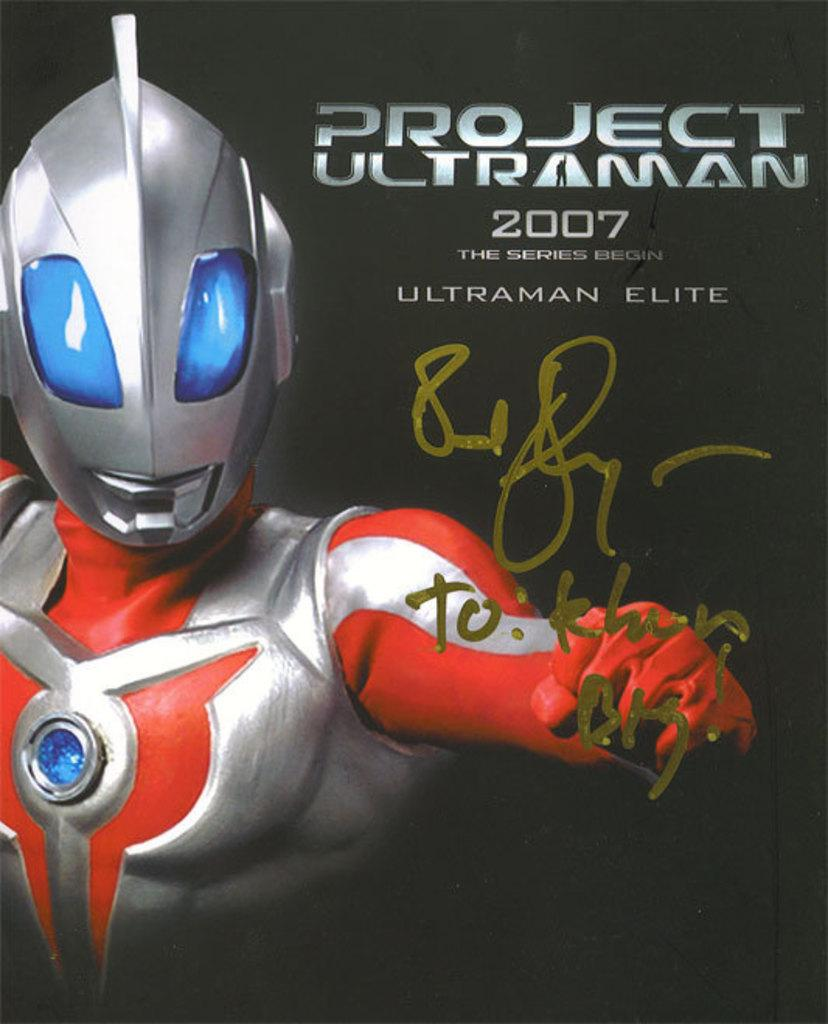What type of image is being described? The image is a poster. What can be seen on the left side of the poster? There is a robot on the left side of the poster. Are there any words or letters on the poster? Yes, there is text on the poster. What color is the background of the poster? The background of the poster is black. How many mice are hiding behind the robot on the poster? There are no mice present on the poster; it features a robot and text on a black background. What type of fuel does the robot use in the image? The image does not provide information about the robot's fuel source, as it only shows the robot and text on a black background. 